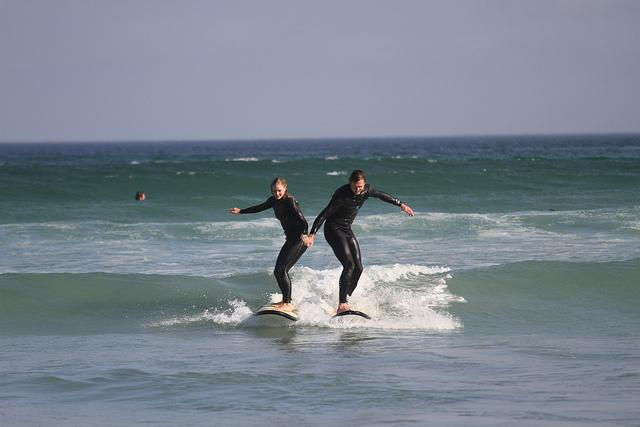How do these people know each other? married 